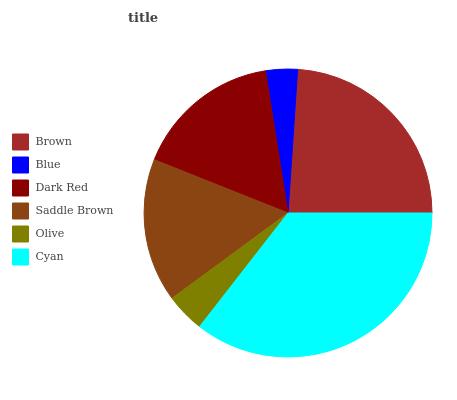Is Blue the minimum?
Answer yes or no. Yes. Is Cyan the maximum?
Answer yes or no. Yes. Is Dark Red the minimum?
Answer yes or no. No. Is Dark Red the maximum?
Answer yes or no. No. Is Dark Red greater than Blue?
Answer yes or no. Yes. Is Blue less than Dark Red?
Answer yes or no. Yes. Is Blue greater than Dark Red?
Answer yes or no. No. Is Dark Red less than Blue?
Answer yes or no. No. Is Dark Red the high median?
Answer yes or no. Yes. Is Saddle Brown the low median?
Answer yes or no. Yes. Is Cyan the high median?
Answer yes or no. No. Is Olive the low median?
Answer yes or no. No. 